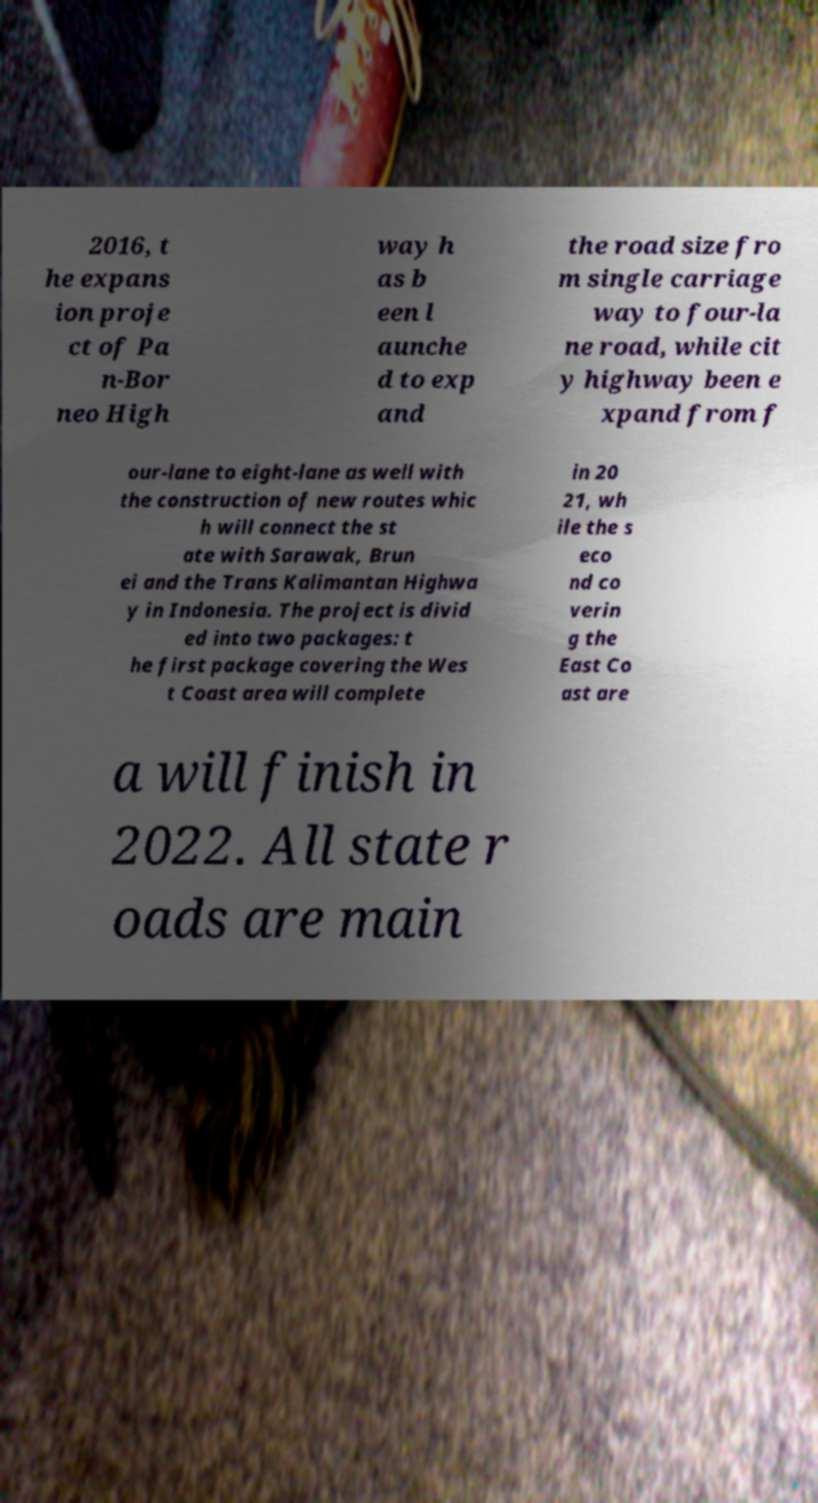Could you assist in decoding the text presented in this image and type it out clearly? 2016, t he expans ion proje ct of Pa n-Bor neo High way h as b een l aunche d to exp and the road size fro m single carriage way to four-la ne road, while cit y highway been e xpand from f our-lane to eight-lane as well with the construction of new routes whic h will connect the st ate with Sarawak, Brun ei and the Trans Kalimantan Highwa y in Indonesia. The project is divid ed into two packages: t he first package covering the Wes t Coast area will complete in 20 21, wh ile the s eco nd co verin g the East Co ast are a will finish in 2022. All state r oads are main 